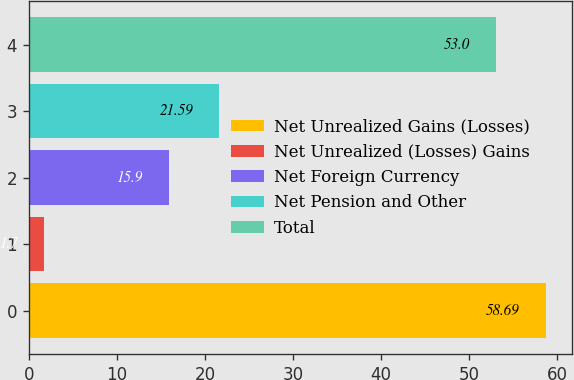Convert chart to OTSL. <chart><loc_0><loc_0><loc_500><loc_500><bar_chart><fcel>Net Unrealized Gains (Losses)<fcel>Net Unrealized (Losses) Gains<fcel>Net Foreign Currency<fcel>Net Pension and Other<fcel>Total<nl><fcel>58.69<fcel>1.7<fcel>15.9<fcel>21.59<fcel>53<nl></chart> 